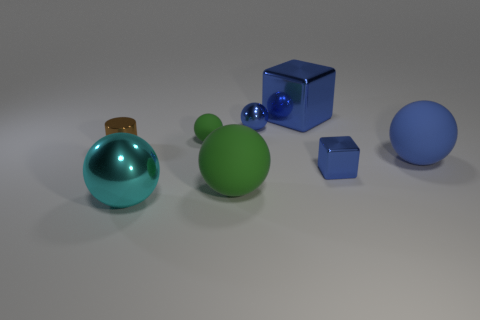The metallic thing that is left of the big blue block and behind the tiny green matte thing has what shape?
Make the answer very short. Sphere. What number of things are big green matte things or blue blocks that are behind the blue matte object?
Ensure brevity in your answer.  2. Are the brown cylinder and the tiny green ball made of the same material?
Keep it short and to the point. No. How many other things are the same shape as the small brown metal object?
Offer a very short reply. 0. What is the size of the ball that is both in front of the big blue rubber sphere and behind the large cyan metal ball?
Offer a terse response. Large. What number of metal things are either spheres or blocks?
Your answer should be very brief. 4. There is a thing that is in front of the large green sphere; is it the same shape as the green rubber object that is right of the tiny matte ball?
Your response must be concise. Yes. Are there any large blue cubes made of the same material as the small blue sphere?
Your answer should be very brief. Yes. The small shiny block is what color?
Ensure brevity in your answer.  Blue. There is a blue sphere that is to the right of the big blue metal cube; how big is it?
Give a very brief answer. Large. 